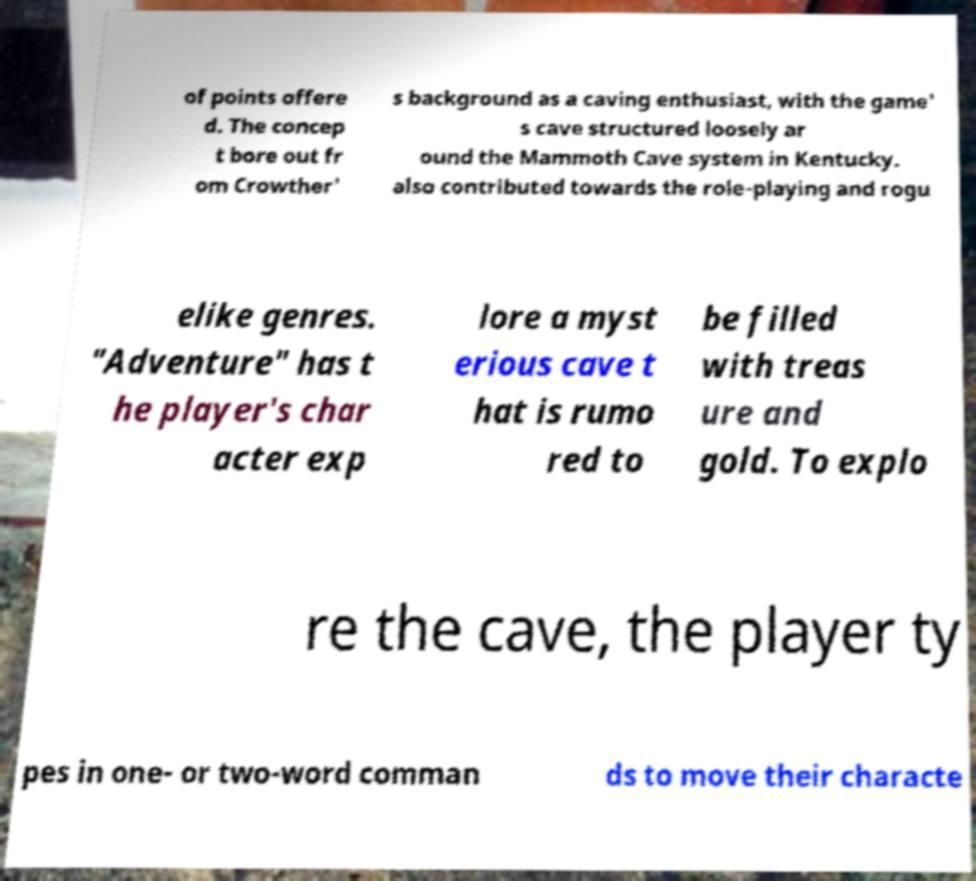I need the written content from this picture converted into text. Can you do that? of points offere d. The concep t bore out fr om Crowther' s background as a caving enthusiast, with the game' s cave structured loosely ar ound the Mammoth Cave system in Kentucky. also contributed towards the role-playing and rogu elike genres. "Adventure" has t he player's char acter exp lore a myst erious cave t hat is rumo red to be filled with treas ure and gold. To explo re the cave, the player ty pes in one- or two-word comman ds to move their characte 